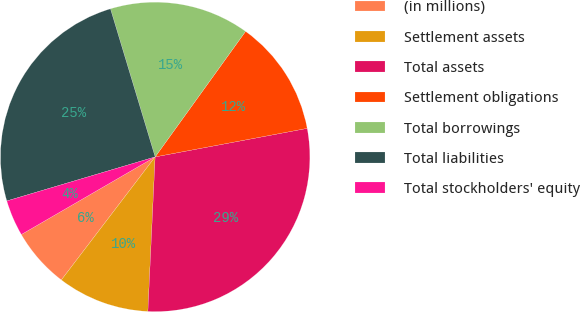Convert chart to OTSL. <chart><loc_0><loc_0><loc_500><loc_500><pie_chart><fcel>(in millions)<fcel>Settlement assets<fcel>Total assets<fcel>Settlement obligations<fcel>Total borrowings<fcel>Total liabilities<fcel>Total stockholders' equity<nl><fcel>6.27%<fcel>9.62%<fcel>28.7%<fcel>12.11%<fcel>14.6%<fcel>24.93%<fcel>3.77%<nl></chart> 